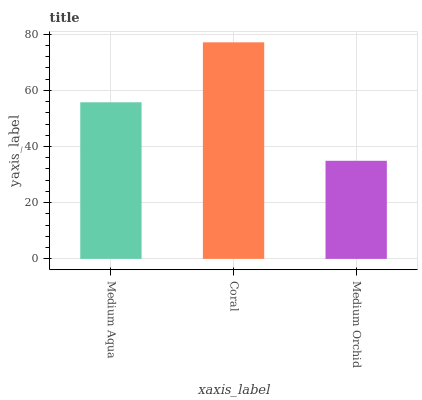Is Medium Orchid the minimum?
Answer yes or no. Yes. Is Coral the maximum?
Answer yes or no. Yes. Is Coral the minimum?
Answer yes or no. No. Is Medium Orchid the maximum?
Answer yes or no. No. Is Coral greater than Medium Orchid?
Answer yes or no. Yes. Is Medium Orchid less than Coral?
Answer yes or no. Yes. Is Medium Orchid greater than Coral?
Answer yes or no. No. Is Coral less than Medium Orchid?
Answer yes or no. No. Is Medium Aqua the high median?
Answer yes or no. Yes. Is Medium Aqua the low median?
Answer yes or no. Yes. Is Coral the high median?
Answer yes or no. No. Is Medium Orchid the low median?
Answer yes or no. No. 